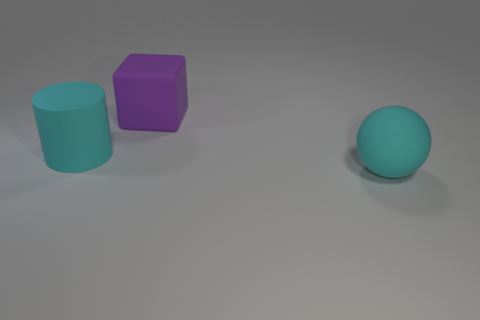There is a cyan matte thing that is in front of the cyan rubber thing behind the object that is in front of the big matte cylinder; what is its size?
Your answer should be compact. Large. What is the color of the big object that is in front of the purple cube and to the right of the matte cylinder?
Ensure brevity in your answer.  Cyan. There is a thing behind the cyan rubber cylinder; what size is it?
Your answer should be compact. Large. How many large cubes are made of the same material as the purple thing?
Your answer should be compact. 0. There is a object that is the same color as the large matte ball; what is its shape?
Provide a short and direct response. Cylinder. Is the shape of the matte object to the right of the big purple block the same as  the purple object?
Your answer should be compact. No. There is a large cylinder that is made of the same material as the big cyan ball; what color is it?
Make the answer very short. Cyan. There is a cyan object that is to the left of the thing right of the big purple block; is there a big purple rubber cube that is in front of it?
Your answer should be very brief. No. The purple rubber object is what shape?
Offer a terse response. Cube. Are there fewer cyan matte spheres that are in front of the cyan cylinder than brown objects?
Provide a succinct answer. No. 